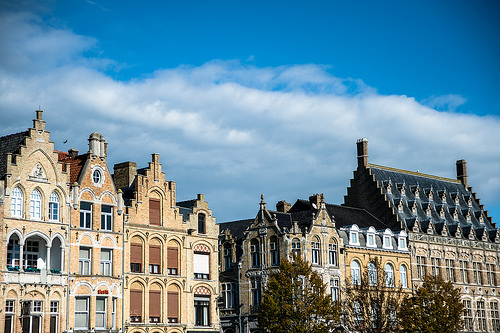<image>
Can you confirm if the sky is behind the palace? Yes. From this viewpoint, the sky is positioned behind the palace, with the palace partially or fully occluding the sky. 